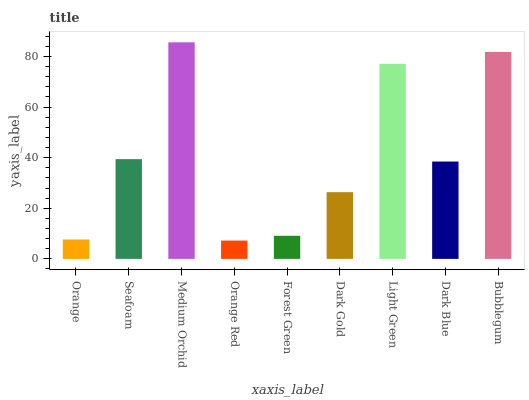Is Seafoam the minimum?
Answer yes or no. No. Is Seafoam the maximum?
Answer yes or no. No. Is Seafoam greater than Orange?
Answer yes or no. Yes. Is Orange less than Seafoam?
Answer yes or no. Yes. Is Orange greater than Seafoam?
Answer yes or no. No. Is Seafoam less than Orange?
Answer yes or no. No. Is Dark Blue the high median?
Answer yes or no. Yes. Is Dark Blue the low median?
Answer yes or no. Yes. Is Forest Green the high median?
Answer yes or no. No. Is Seafoam the low median?
Answer yes or no. No. 